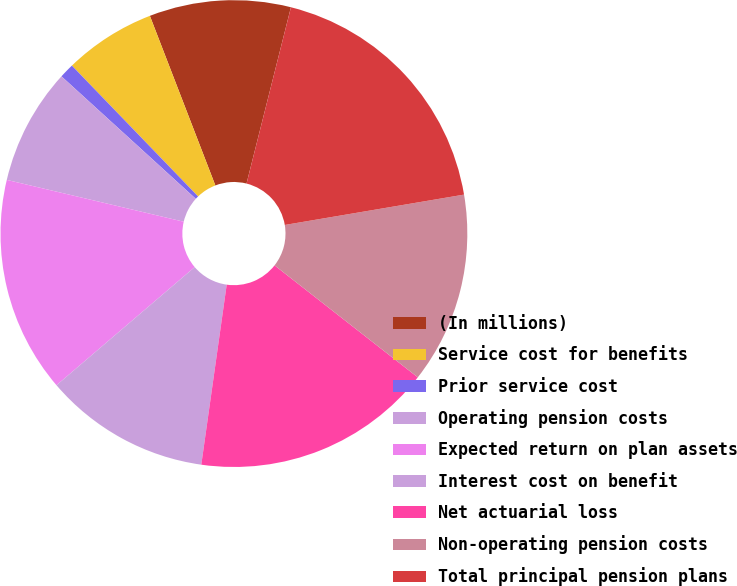<chart> <loc_0><loc_0><loc_500><loc_500><pie_chart><fcel>(In millions)<fcel>Service cost for benefits<fcel>Prior service cost<fcel>Operating pension costs<fcel>Expected return on plan assets<fcel>Interest cost on benefit<fcel>Net actuarial loss<fcel>Non-operating pension costs<fcel>Total principal pension plans<nl><fcel>9.79%<fcel>6.35%<fcel>1.02%<fcel>8.07%<fcel>14.95%<fcel>11.51%<fcel>16.67%<fcel>13.23%<fcel>18.4%<nl></chart> 